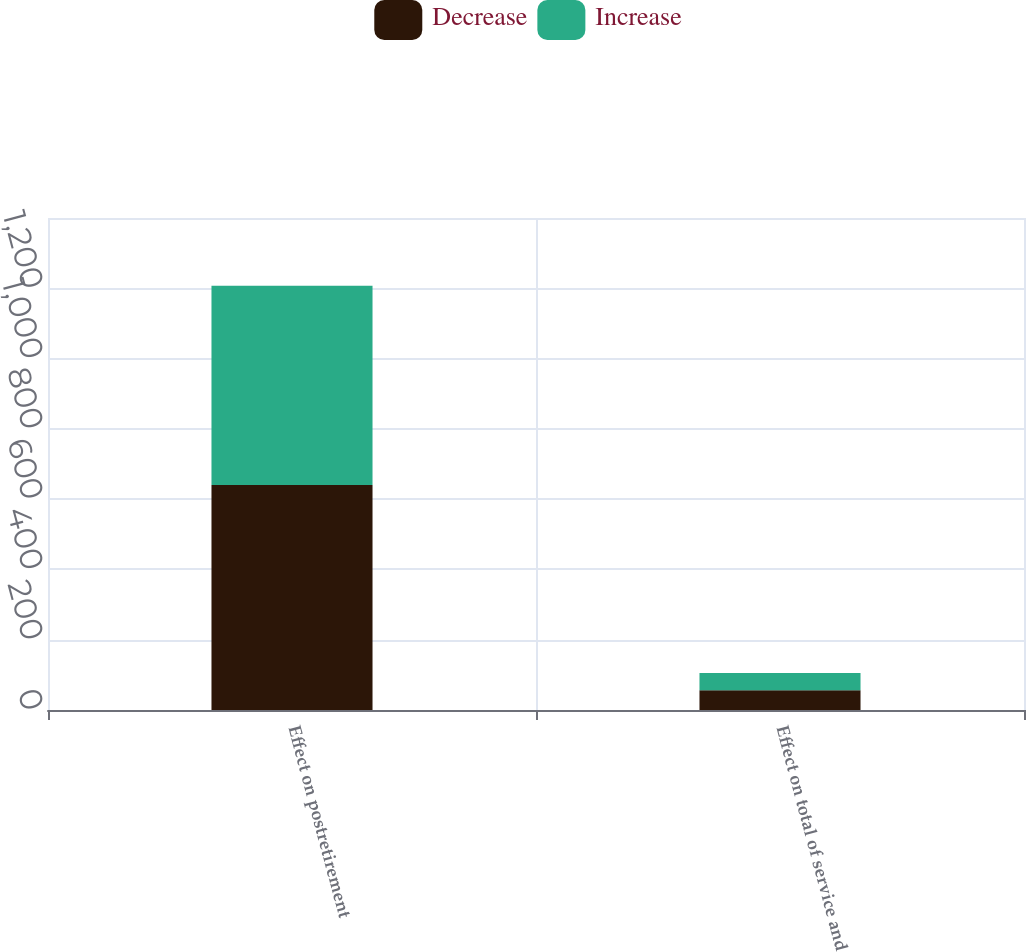Convert chart. <chart><loc_0><loc_0><loc_500><loc_500><stacked_bar_chart><ecel><fcel>Effect on postretirement<fcel>Effect on total of service and<nl><fcel>Decrease<fcel>640<fcel>56<nl><fcel>Increase<fcel>567<fcel>49<nl></chart> 